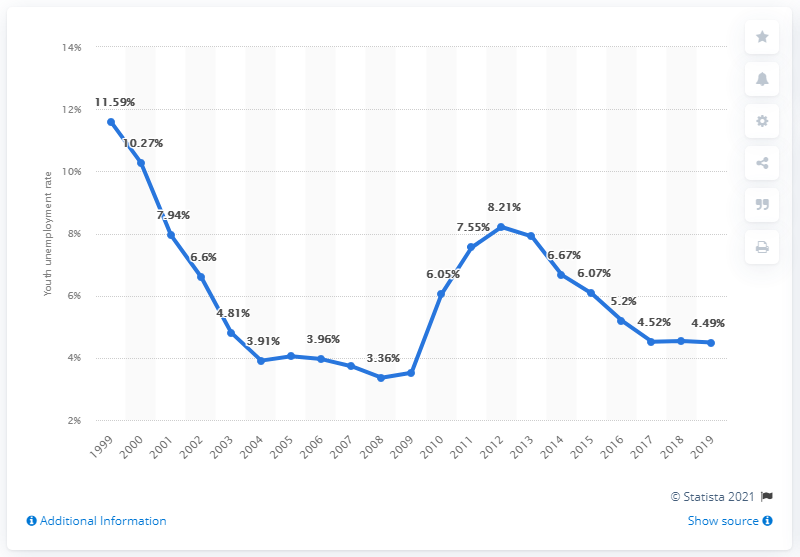Point out several critical features in this image. The youth unemployment rate in Cuba in 2019 was 4.49%. 